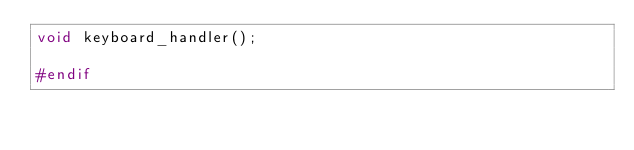<code> <loc_0><loc_0><loc_500><loc_500><_C_>void keyboard_handler();

#endif
</code> 